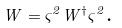<formula> <loc_0><loc_0><loc_500><loc_500>W = \varsigma ^ { 2 } W ^ { \dagger } \varsigma ^ { 2 } \text {.}</formula> 